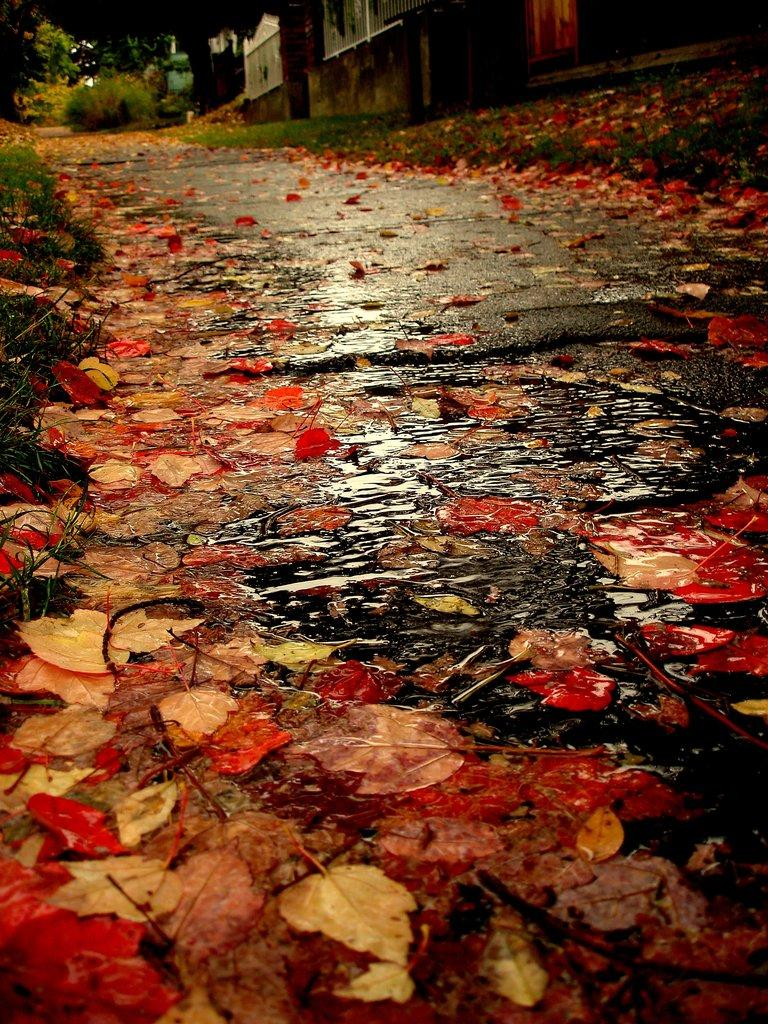What is present at the bottom of the image? There is water and leaves at the bottom of the image. What type of vegetation is on the left side of the image? There is grass on the left side of the image. What can be seen in the background of the image? There are plants and a house in the background of the image. Can you see the face of the goat in the image? There is no goat present in the image. What type of insurance is being advertised on the house in the image? There is no advertisement or mention of insurance in the image. 